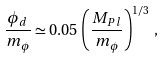Convert formula to latex. <formula><loc_0><loc_0><loc_500><loc_500>\frac { \phi _ { d } } { m _ { \phi } } \simeq 0 . 0 5 \, \left ( \frac { M _ { P l } } { m _ { \phi } } \right ) ^ { 1 / 3 } \, ,</formula> 